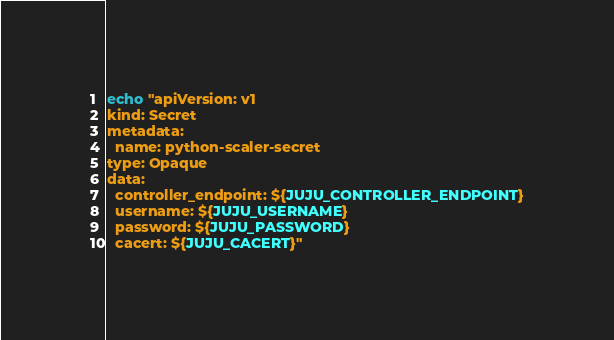Convert code to text. <code><loc_0><loc_0><loc_500><loc_500><_Bash_>echo "apiVersion: v1
kind: Secret
metadata:
  name: python-scaler-secret
type: Opaque
data:
  controller_endpoint: ${JUJU_CONTROLLER_ENDPOINT}
  username: ${JUJU_USERNAME}
  password: ${JUJU_PASSWORD}
  cacert: ${JUJU_CACERT}"
</code> 